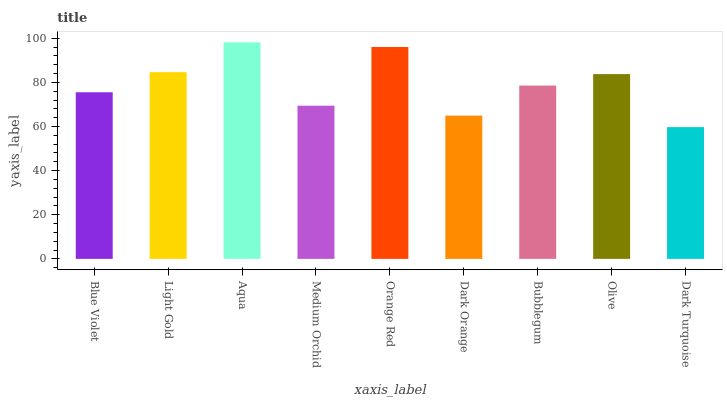Is Dark Turquoise the minimum?
Answer yes or no. Yes. Is Aqua the maximum?
Answer yes or no. Yes. Is Light Gold the minimum?
Answer yes or no. No. Is Light Gold the maximum?
Answer yes or no. No. Is Light Gold greater than Blue Violet?
Answer yes or no. Yes. Is Blue Violet less than Light Gold?
Answer yes or no. Yes. Is Blue Violet greater than Light Gold?
Answer yes or no. No. Is Light Gold less than Blue Violet?
Answer yes or no. No. Is Bubblegum the high median?
Answer yes or no. Yes. Is Bubblegum the low median?
Answer yes or no. Yes. Is Medium Orchid the high median?
Answer yes or no. No. Is Blue Violet the low median?
Answer yes or no. No. 